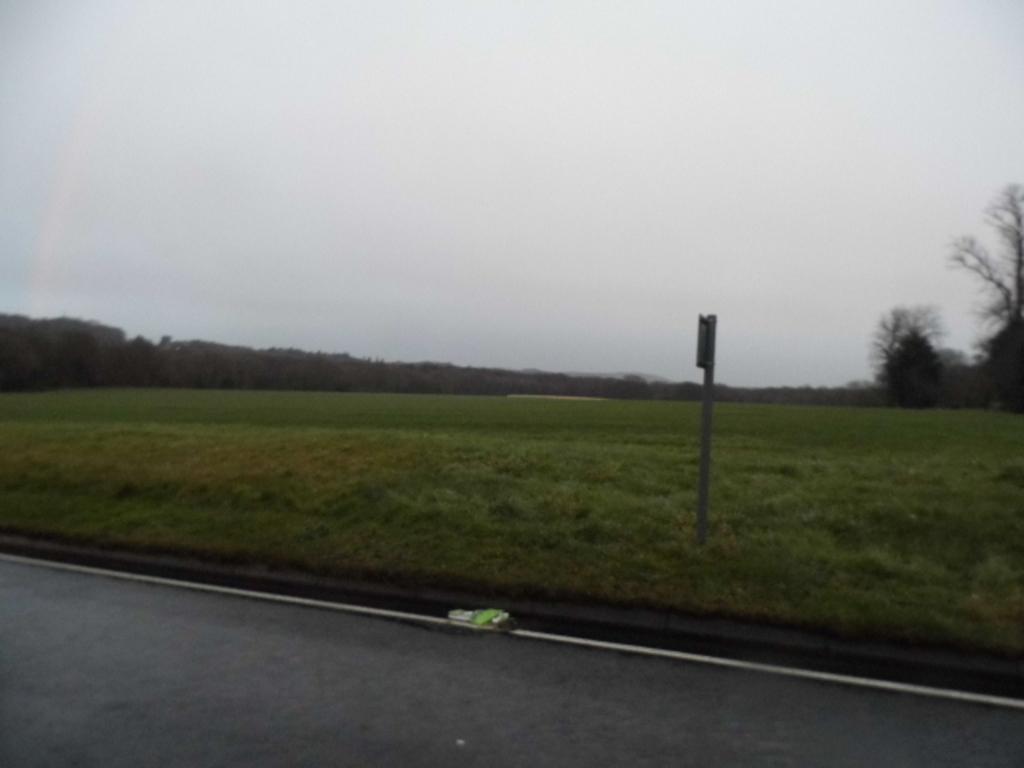Describe this image in one or two sentences. In this image I can see grass, pole, vehicle on the road, trees and the sky. This image is taken may be near the farms. 